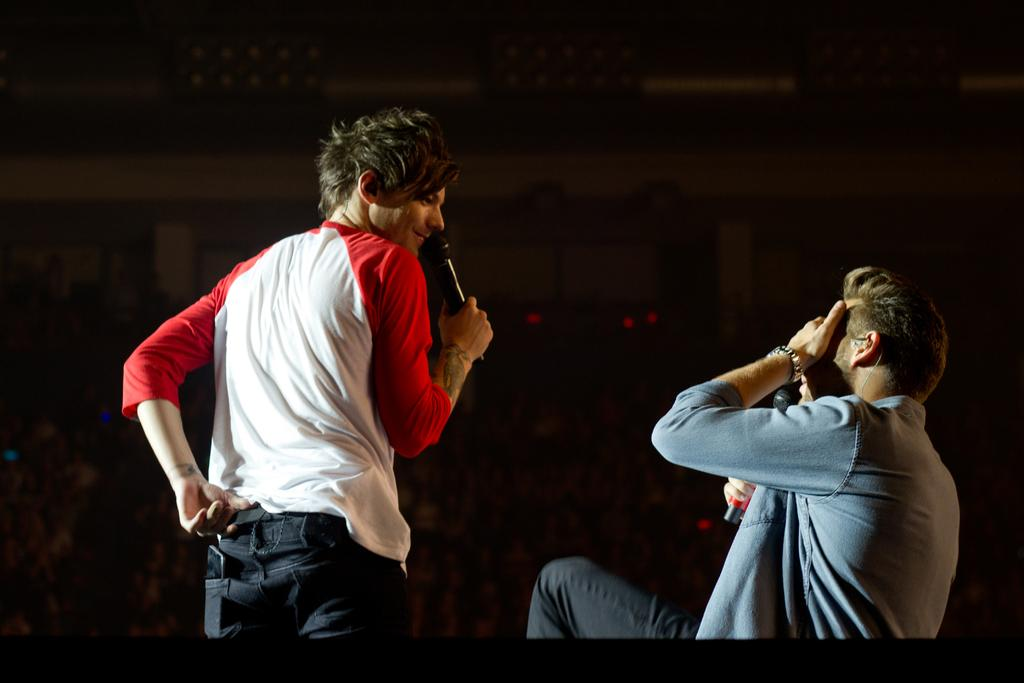How many people are in the image? There are two persons in the image. What are the persons holding in the image? The persons are holding microphones. What can be observed about the background of the image? The background of the image is dark. Can you see the grandmother's wing in the image? There is no grandmother or wing present in the image. 